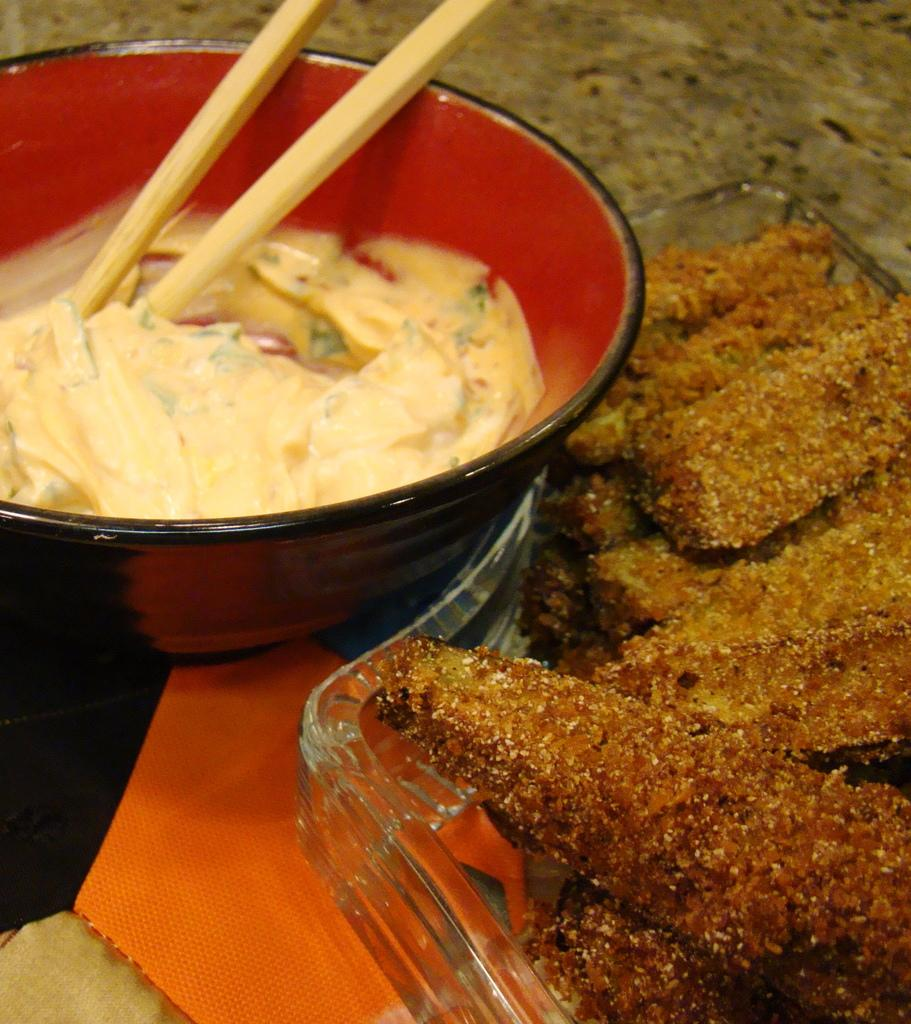What is in the bowl that is visible in the image? There is a bowl with food in it. What utensil is present in the bowl? Chopsticks are present in the bowl. What is on the plate that is visible in the image? There is a plate with food in it. What position does the head of lettuce take in the image? There is no head of lettuce present in the image. 